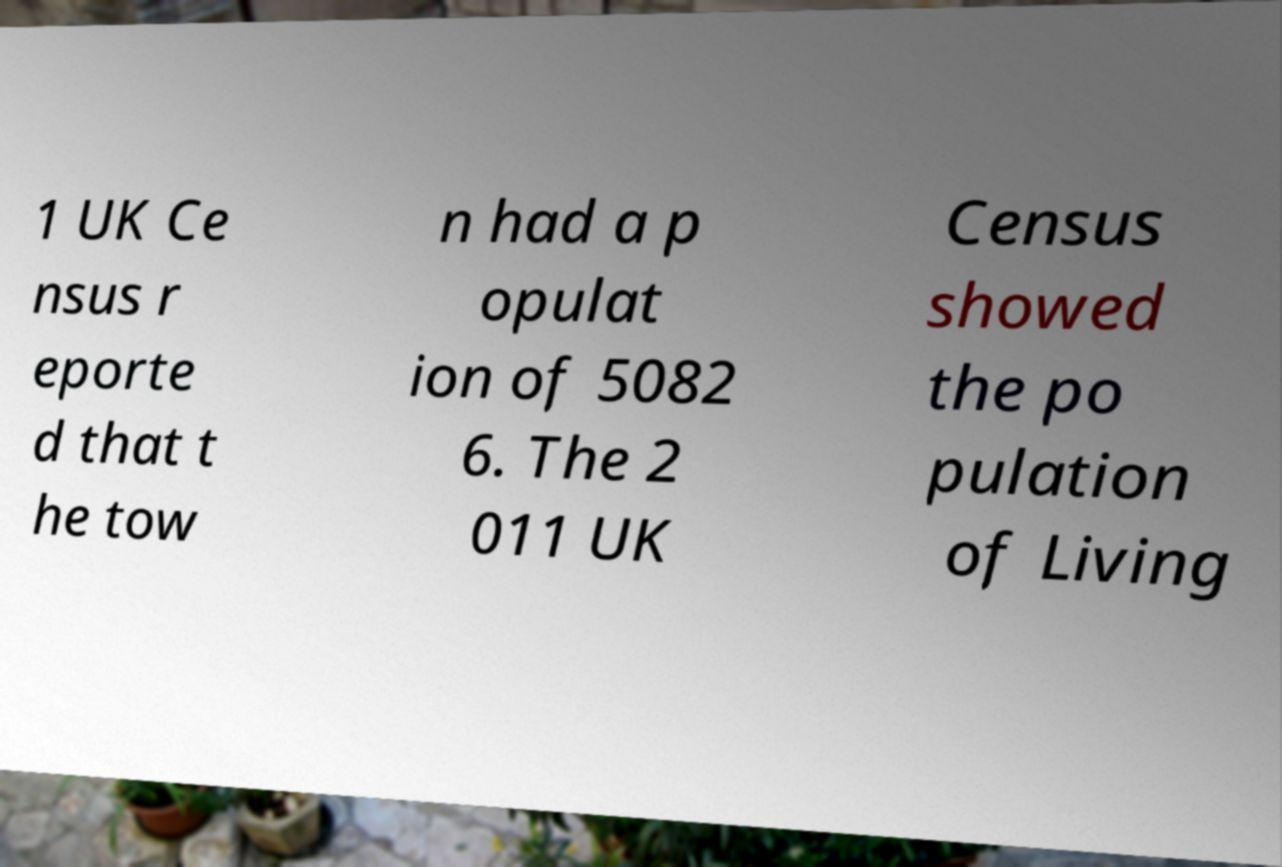I need the written content from this picture converted into text. Can you do that? 1 UK Ce nsus r eporte d that t he tow n had a p opulat ion of 5082 6. The 2 011 UK Census showed the po pulation of Living 